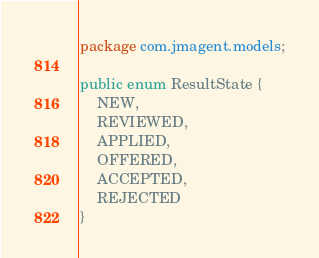Convert code to text. <code><loc_0><loc_0><loc_500><loc_500><_Java_>package com.jmagent.models;

public enum ResultState {
    NEW,
    REVIEWED,
    APPLIED,
    OFFERED,
    ACCEPTED,
    REJECTED
}</code> 